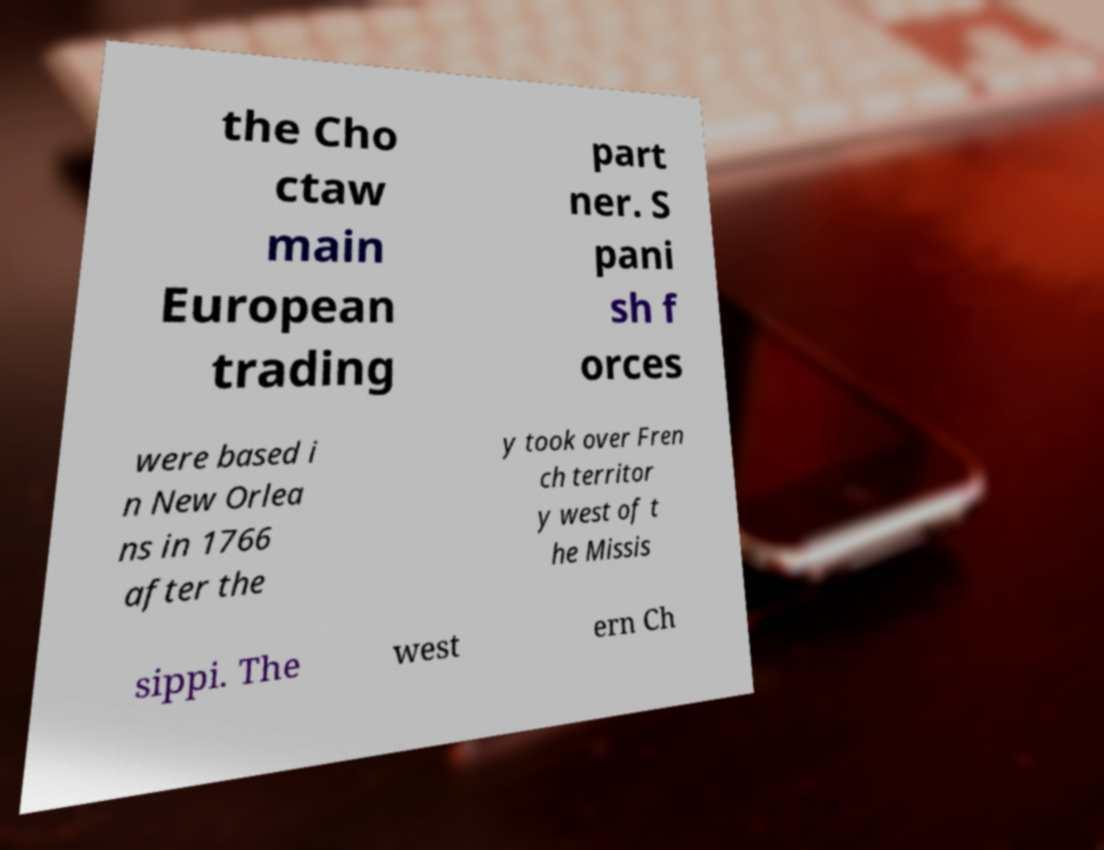Could you assist in decoding the text presented in this image and type it out clearly? the Cho ctaw main European trading part ner. S pani sh f orces were based i n New Orlea ns in 1766 after the y took over Fren ch territor y west of t he Missis sippi. The west ern Ch 